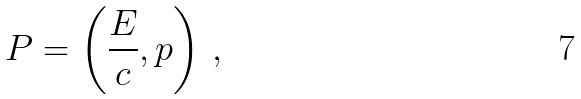<formula> <loc_0><loc_0><loc_500><loc_500>P = \left ( { \frac { E } { c } } , p \right ) \, ,</formula> 